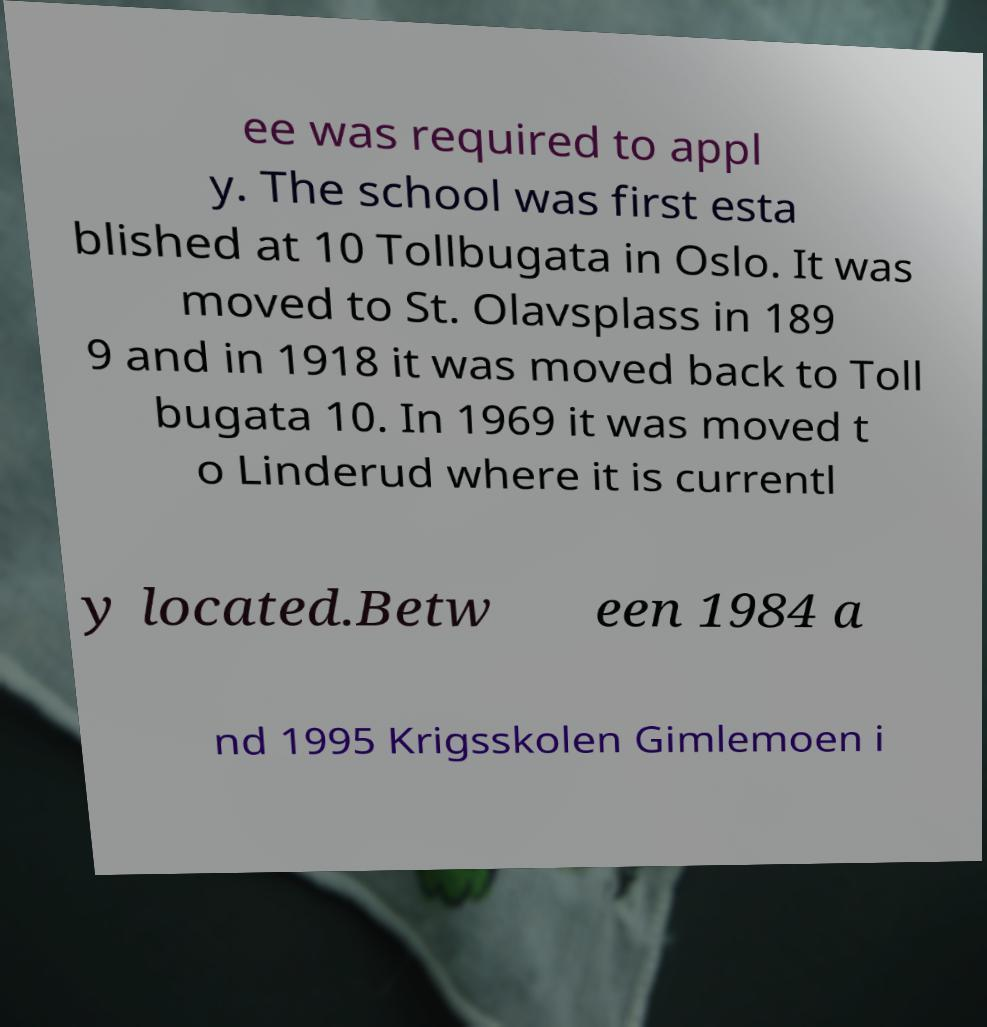There's text embedded in this image that I need extracted. Can you transcribe it verbatim? ee was required to appl y. The school was first esta blished at 10 Tollbugata in Oslo. It was moved to St. Olavsplass in 189 9 and in 1918 it was moved back to Toll bugata 10. In 1969 it was moved t o Linderud where it is currentl y located.Betw een 1984 a nd 1995 Krigsskolen Gimlemoen i 